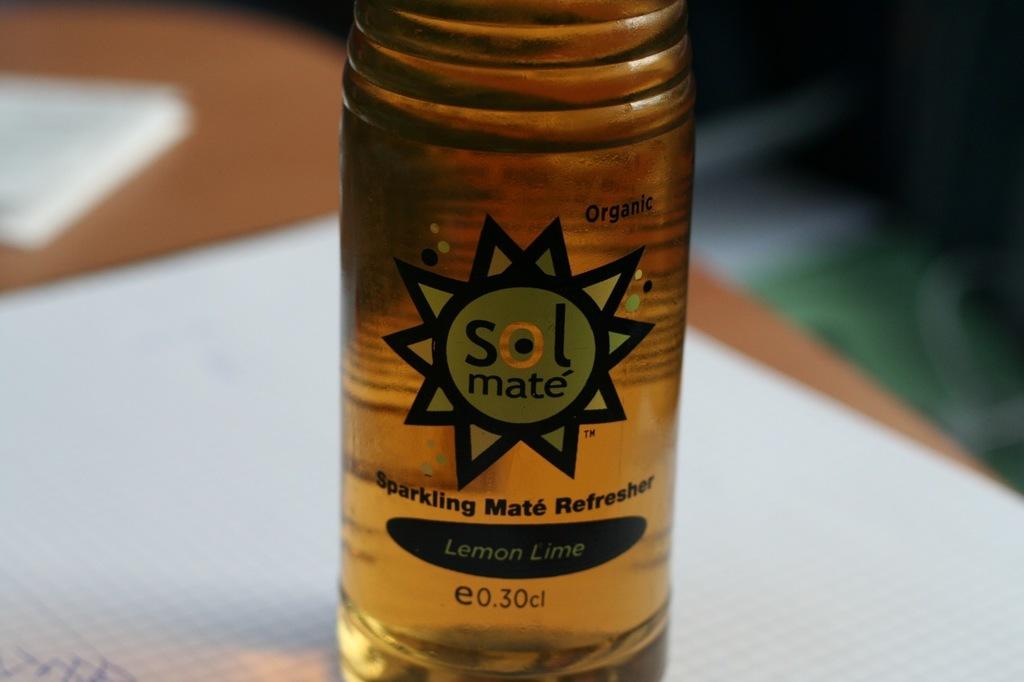What flavor is this beverage?
Make the answer very short. Lemon lime. What is the brand of this drink?
Your answer should be compact. Sol mate. 